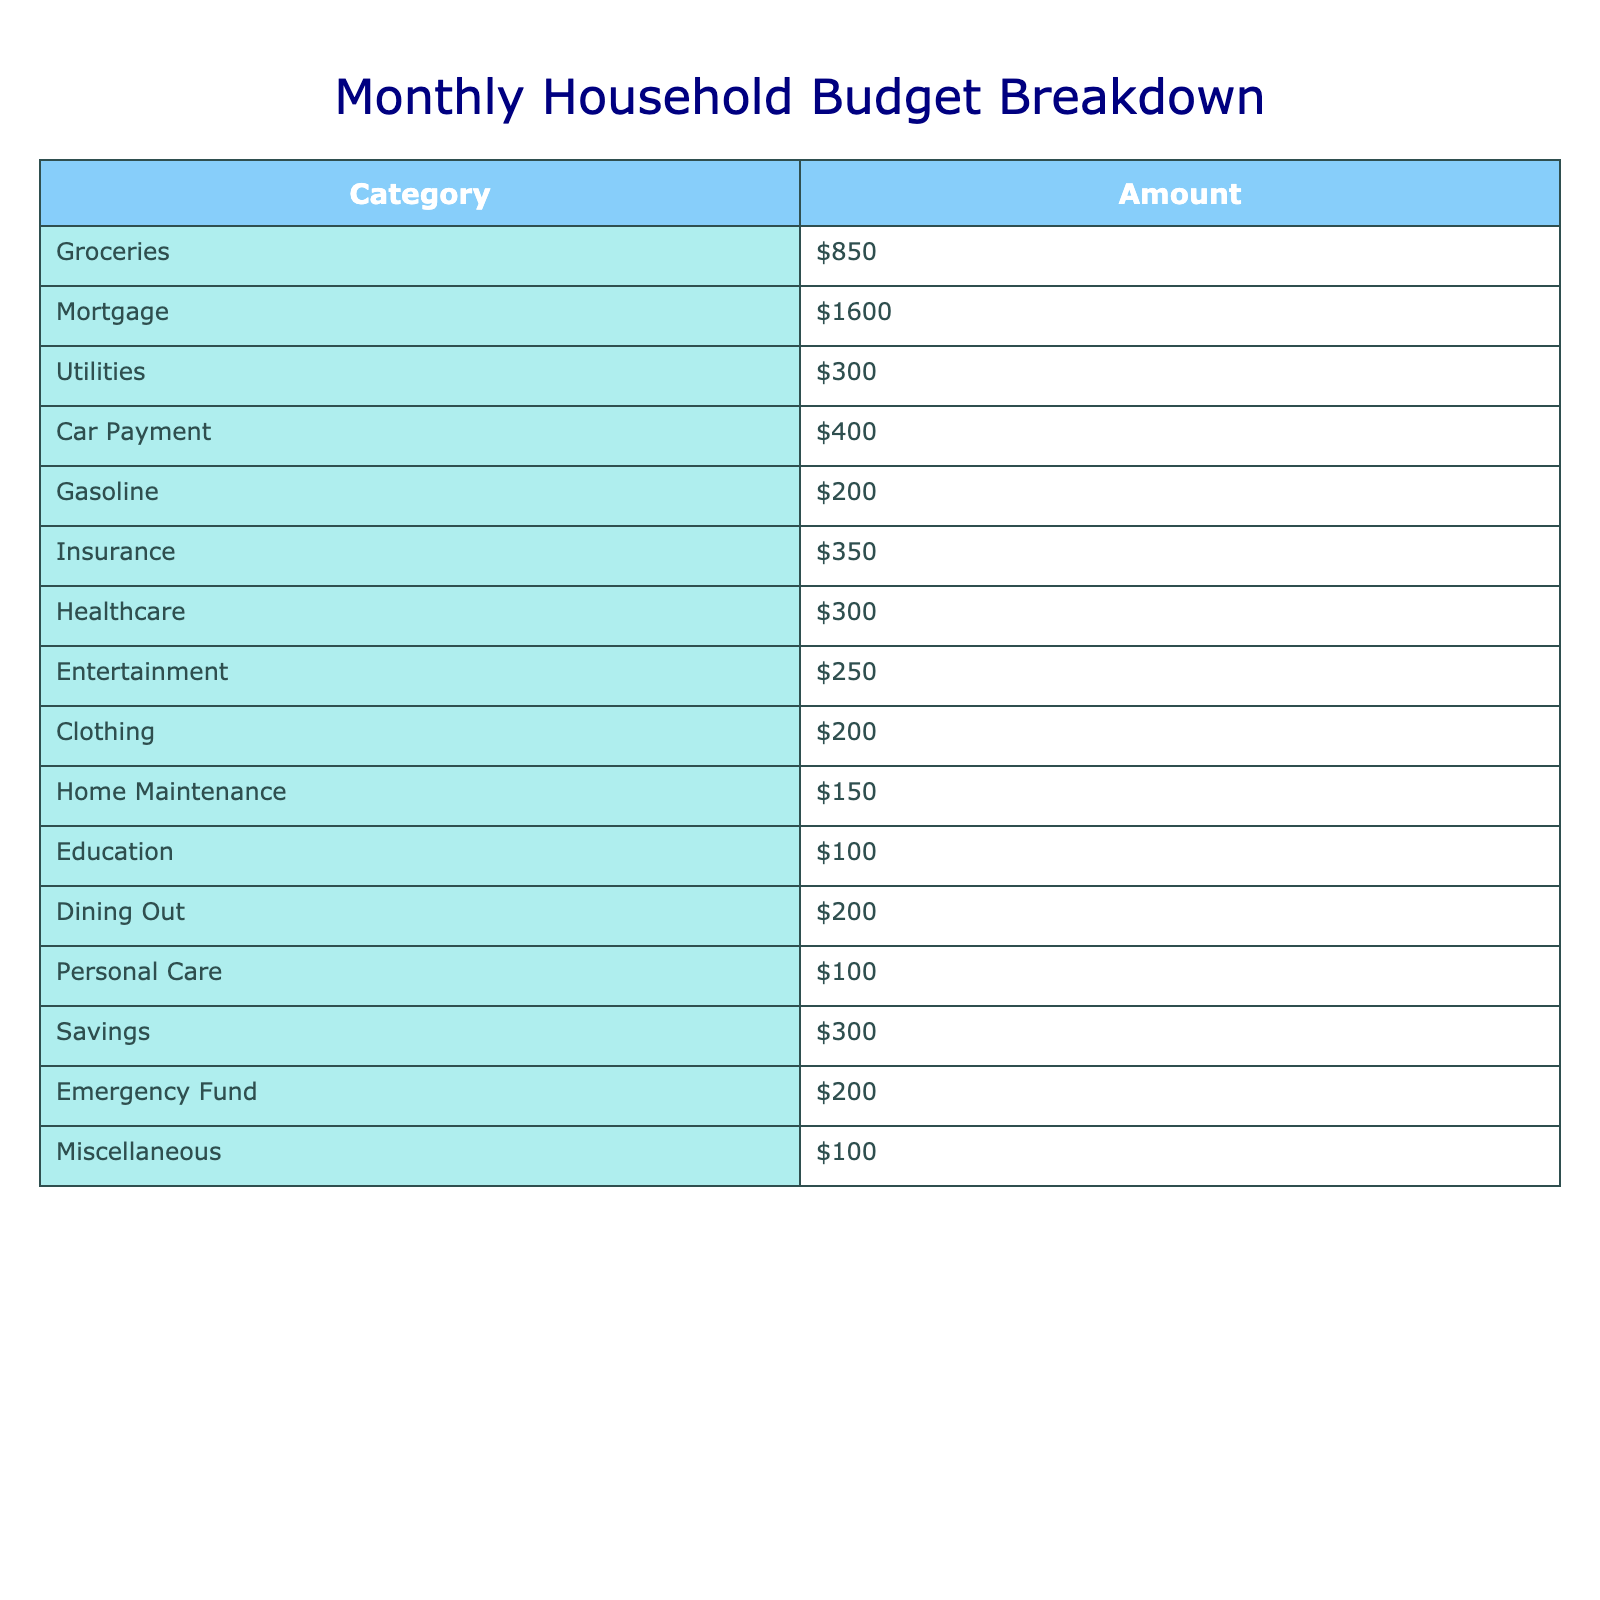What is the total amount allocated to groceries? The table shows that the amount allocated to groceries is $850.
Answer: $850 What is the largest expense category in this budget? The largest expense category can be identified by comparing the amounts. The mortgage at $1600 is higher than all other categories.
Answer: Mortgage What is the total sum of all expenses listed in the table? To calculate the total sum, we add each category: $850 + $1600 + $300 + $400 + $200 + $350 + $300 + $250 + $200 + $150 + $100 + $200 + $100 + $300 + $200 + $100 = $5,400.
Answer: $5,400 What percentage of the total budget is spent on entertainment? First, we need the total budget, which is $5,400. The entertainment expense is $250. The percentage is calculated as ($250/$5400) * 100 = approximately 4.63%.
Answer: 4.63% Is the amount spent on healthcare greater than that spent on clothing? The healthcare expense is $300 and the clothing expense is $200. Since $300 is greater than $200, the statement is true.
Answer: Yes What is the difference between the mortgage payment and the amount allocated for personal care? The mortgage is $1600 and personal care is $100. The difference is calculated as $1600 - $100 = $1500.
Answer: $1500 If the family decides to cut their entertainment budget in half, how much will they save from that category? The current entertainment budget is $250. Cutting it in half means the new budget will be $250 / 2 = $125. The savings will be $250 - $125 = $125.
Answer: $125 What is the combined total for utilities and gasoline? The utilities cost $300 and gasoline costs $200. The combined total is $300 + $200 = $500.
Answer: $500 What is the smallest expense listed in the table? By reviewing all the categories, the smallest expense is the education category at $100.
Answer: $100 How much more does the family spend on mortgage compared to gas? The mortgage payment is $1600, and gasoline costs $200. The difference is $1600 - $200 = $1400.
Answer: $1400 